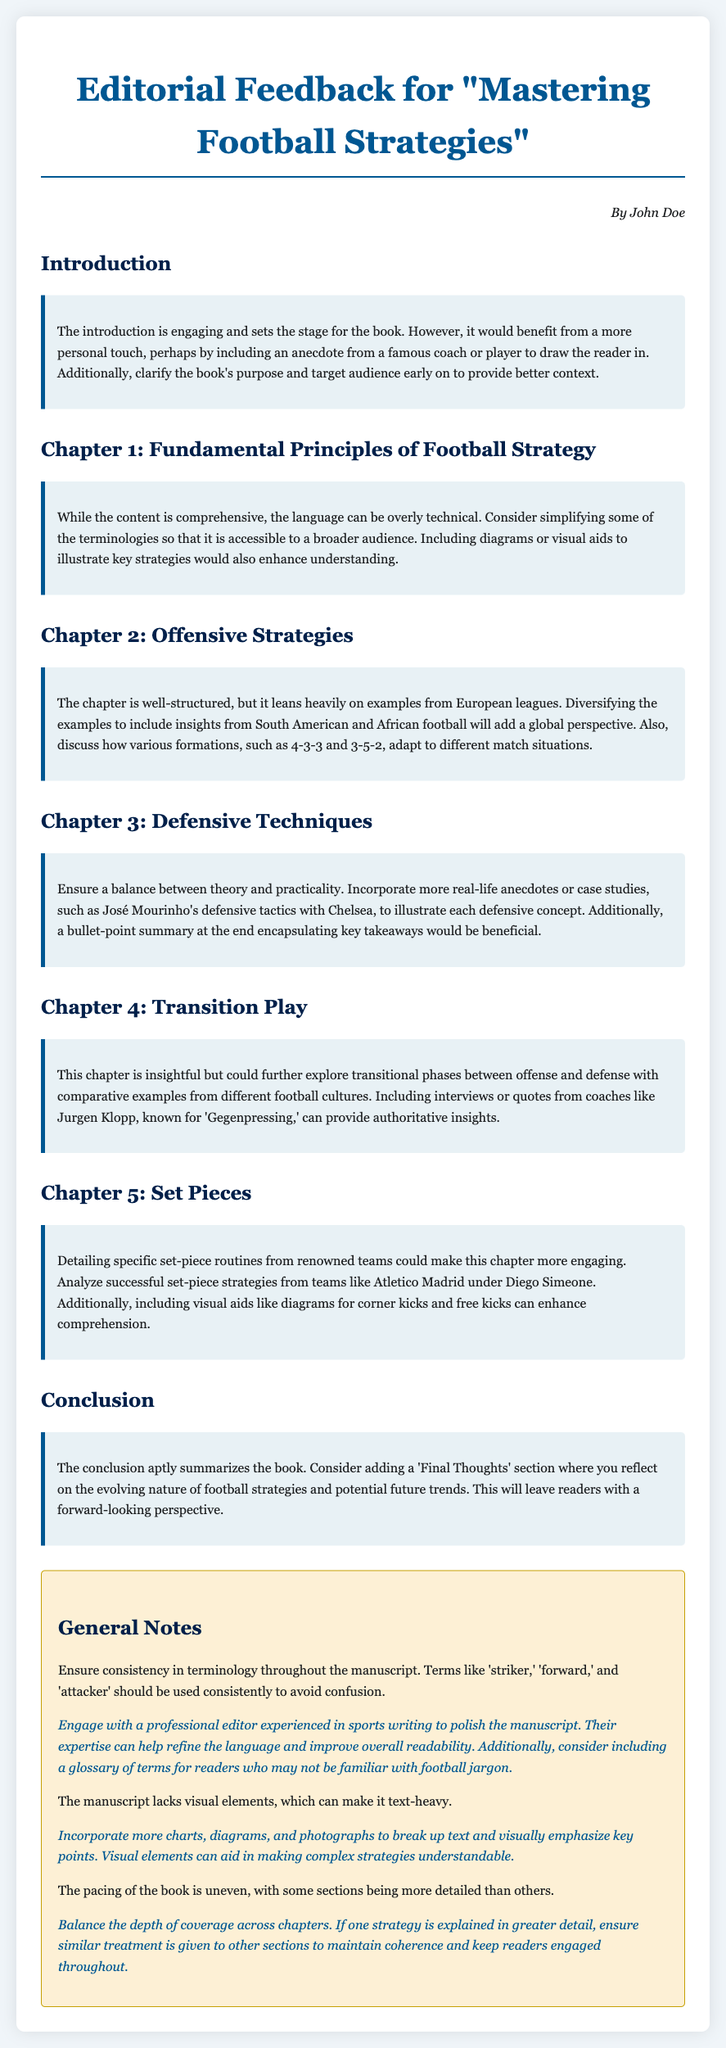What is the title of the manuscript? The title is mentioned in the document's heading, stating the subject of the review.
Answer: Mastering Football Strategies Who authored the editorial feedback? The author's name is provided at the bottom of the document above the general notes section.
Answer: John Doe What is a suggested change mentioned for the introduction? The feedback specifies a need for a personal touch or an anecdote to engage readers.
Answer: Include an anecdote Which chapter discusses offensive strategies? The chapter titles are clearly listed, specifying the content focus of each.
Answer: Chapter 2 What does the general notes section suggest for visual elements? The suggestions in the section point out improvements related to visual aids.
Answer: Incorporate more charts, diagrams, and photographs What is the suggested addition to the conclusion? The conclusion feedback recommends introducing a forward-looking perspective on strategies.
Answer: Add a 'Final Thoughts' section What is a reason provided for diversifying examples in Chapter 2? The feedback indicates a lack of variety in the examples used which should be addressed.
Answer: Add a global perspective Which chapter needs more real-life anecdotes according to the feedback? The content reviews indicate a need for more practical examples in specific chapters.
Answer: Chapter 3 What should be consistent throughout the manuscript? The general notes emphasize the importance of uniformity in specific terminology to avoid confusion.
Answer: Terminology consistency 